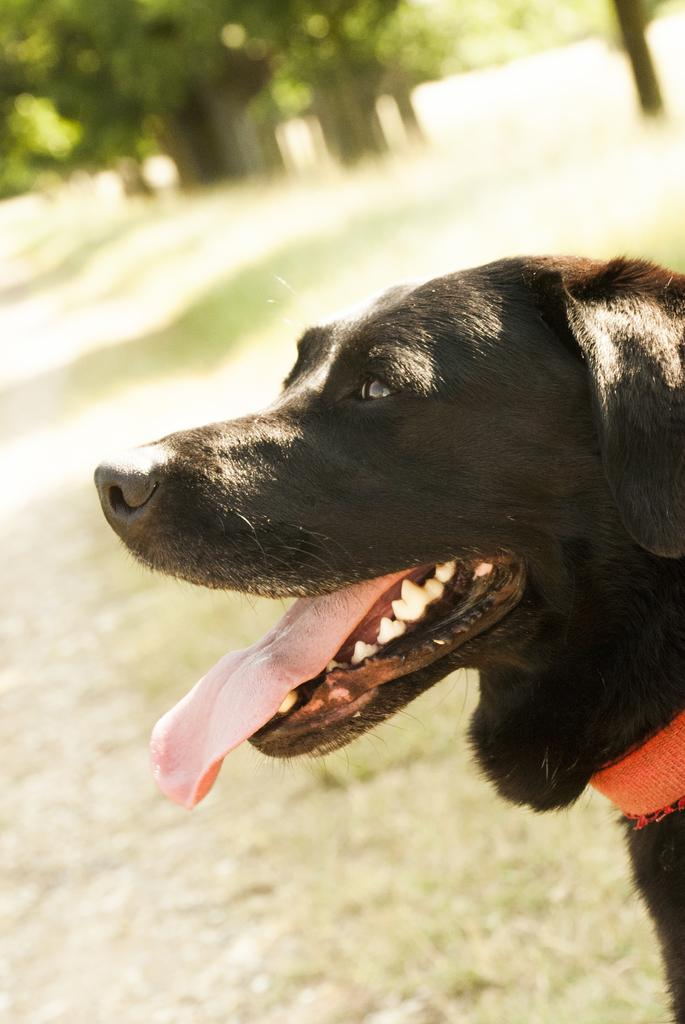What type of animal is in the image? There is a black color dog in the image. Where is the dog located in the image? The dog is in the front of the image. What type of vegetation is present in the image? There is grass in the image. What can be seen in the background of the image? There are trees in the background of the image. How is the background of the image depicted? The background is slightly blurred. What type of jeans is the sheep wearing in the image? There is no sheep or jeans present in the image. 